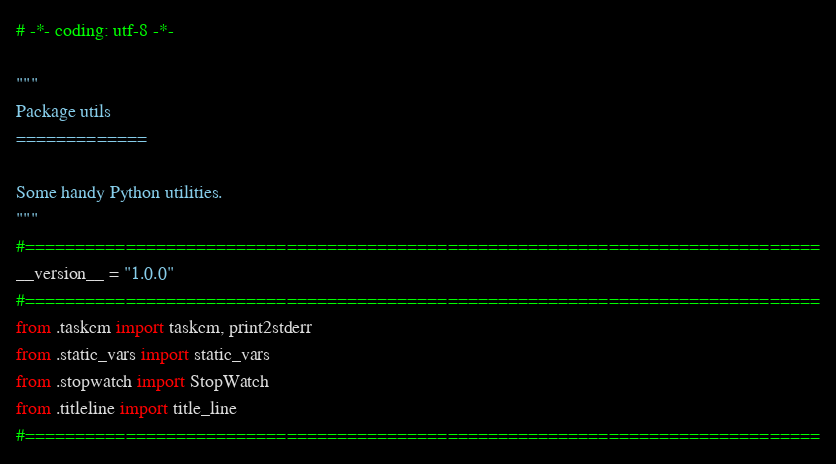<code> <loc_0><loc_0><loc_500><loc_500><_Python_># -*- coding: utf-8 -*-

"""
Package utils
=============

Some handy Python utilities.
"""
#===============================================================================
__version__ = "1.0.0"
#===============================================================================
from .taskcm import taskcm, print2stderr
from .static_vars import static_vars
from .stopwatch import StopWatch
from .titleline import title_line
#===============================================================================
</code> 